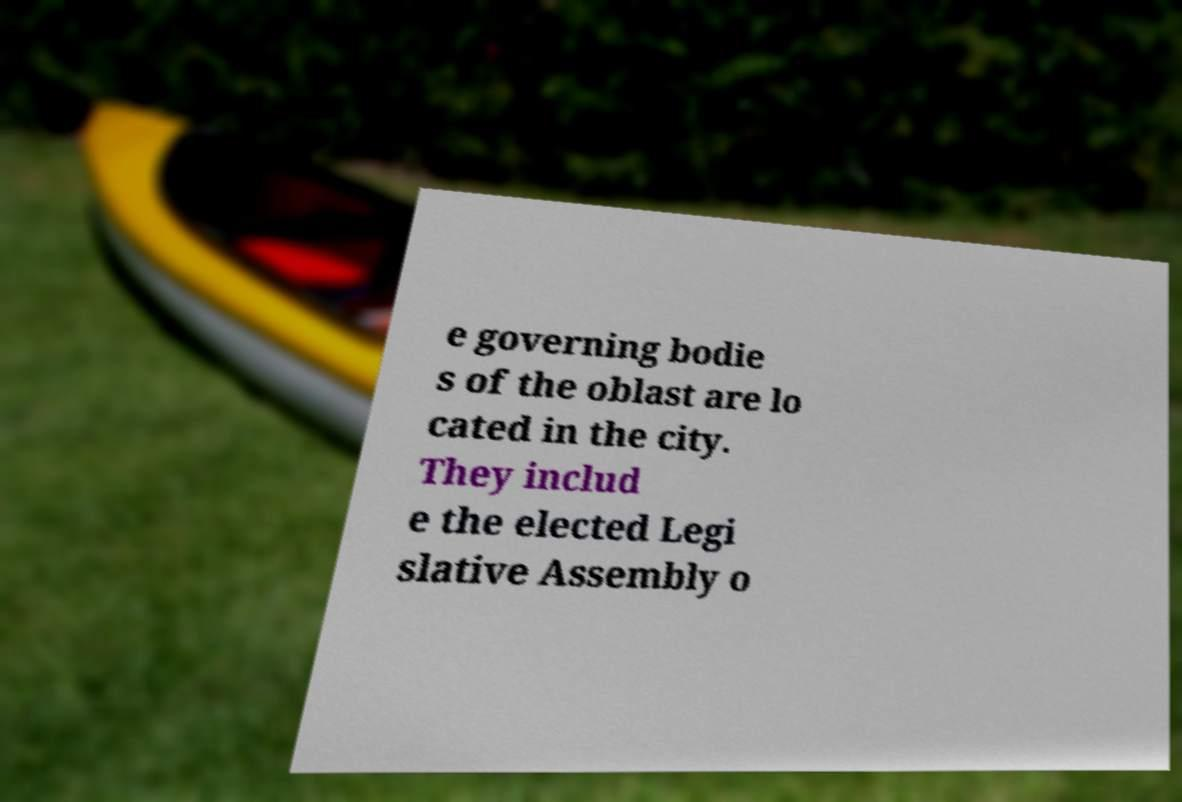Could you extract and type out the text from this image? e governing bodie s of the oblast are lo cated in the city. They includ e the elected Legi slative Assembly o 